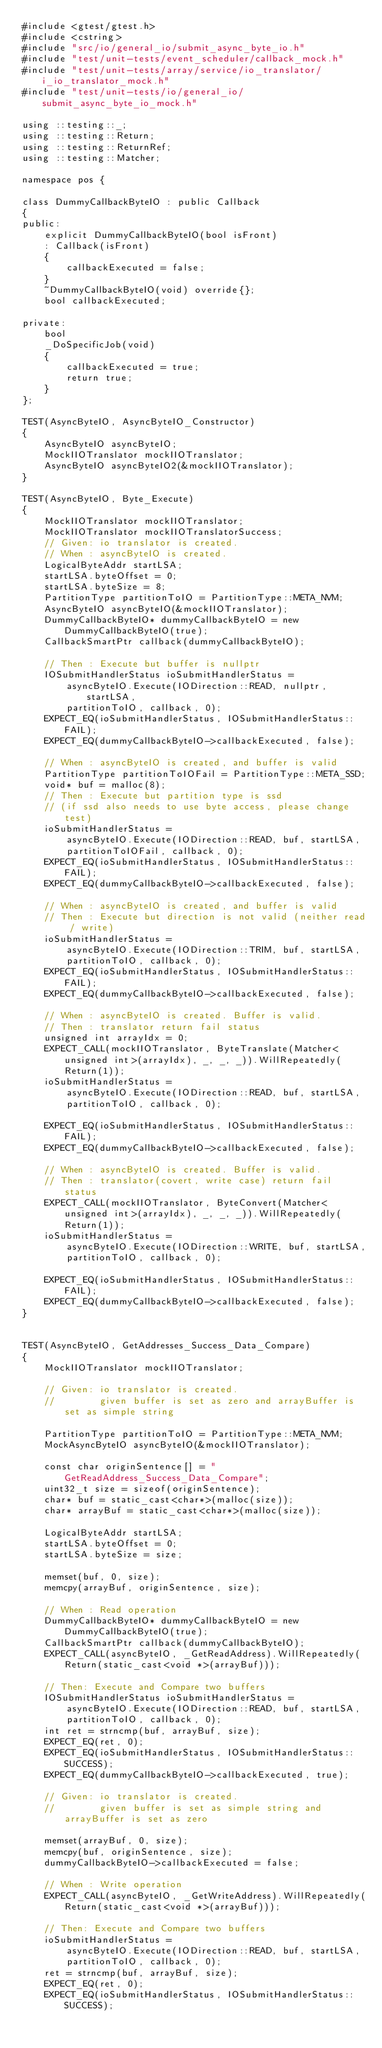<code> <loc_0><loc_0><loc_500><loc_500><_C++_>#include <gtest/gtest.h>
#include <cstring>
#include "src/io/general_io/submit_async_byte_io.h"
#include "test/unit-tests/event_scheduler/callback_mock.h"
#include "test/unit-tests/array/service/io_translator/i_io_translator_mock.h"
#include "test/unit-tests/io/general_io/submit_async_byte_io_mock.h"

using ::testing::_;
using ::testing::Return;
using ::testing::ReturnRef;
using ::testing::Matcher;

namespace pos {

class DummyCallbackByteIO : public Callback
{
public:
    explicit DummyCallbackByteIO(bool isFront)
    : Callback(isFront)
    {
        callbackExecuted = false;
    }
    ~DummyCallbackByteIO(void) override{};
    bool callbackExecuted;

private:
    bool
    _DoSpecificJob(void)
    {
        callbackExecuted = true;
        return true;
    }
};

TEST(AsyncByteIO, AsyncByteIO_Constructor)
{
    AsyncByteIO asyncByteIO;
    MockIIOTranslator mockIIOTranslator;
    AsyncByteIO asyncByteIO2(&mockIIOTranslator);
}

TEST(AsyncByteIO, Byte_Execute)
{
    MockIIOTranslator mockIIOTranslator;
    MockIIOTranslator mockIIOTranslatorSuccess;
    // Given: io translator is created.
    // When : asyncByteIO is created.
    LogicalByteAddr startLSA;
    startLSA.byteOffset = 0;
    startLSA.byteSize = 8;
    PartitionType partitionToIO = PartitionType::META_NVM;
    AsyncByteIO asyncByteIO(&mockIIOTranslator);
    DummyCallbackByteIO* dummyCallbackByteIO = new DummyCallbackByteIO(true);
    CallbackSmartPtr callback(dummyCallbackByteIO);

    // Then : Execute but buffer is nullptr
    IOSubmitHandlerStatus ioSubmitHandlerStatus =
        asyncByteIO.Execute(IODirection::READ, nullptr, startLSA,
        partitionToIO, callback, 0);
    EXPECT_EQ(ioSubmitHandlerStatus, IOSubmitHandlerStatus::FAIL);
    EXPECT_EQ(dummyCallbackByteIO->callbackExecuted, false);

    // When : asyncByteIO is created, and buffer is valid
    PartitionType partitionToIOFail = PartitionType::META_SSD;
    void* buf = malloc(8);
    // Then : Execute but partition type is ssd
    // (if ssd also needs to use byte access, please change test)
    ioSubmitHandlerStatus =
        asyncByteIO.Execute(IODirection::READ, buf, startLSA,
        partitionToIOFail, callback, 0);
    EXPECT_EQ(ioSubmitHandlerStatus, IOSubmitHandlerStatus::FAIL);
    EXPECT_EQ(dummyCallbackByteIO->callbackExecuted, false);

    // When : asyncByteIO is created, and buffer is valid
    // Then : Execute but direction is not valid (neither read / write)
    ioSubmitHandlerStatus =
        asyncByteIO.Execute(IODirection::TRIM, buf, startLSA,
        partitionToIO, callback, 0);
    EXPECT_EQ(ioSubmitHandlerStatus, IOSubmitHandlerStatus::FAIL);
    EXPECT_EQ(dummyCallbackByteIO->callbackExecuted, false);

    // When : asyncByteIO is created. Buffer is valid.
    // Then : translator return fail status
    unsigned int arrayIdx = 0;
    EXPECT_CALL(mockIIOTranslator, ByteTranslate(Matcher<unsigned int>(arrayIdx), _, _, _)).WillRepeatedly(Return(1));
    ioSubmitHandlerStatus =
        asyncByteIO.Execute(IODirection::READ, buf, startLSA,
        partitionToIO, callback, 0);

    EXPECT_EQ(ioSubmitHandlerStatus, IOSubmitHandlerStatus::FAIL);
    EXPECT_EQ(dummyCallbackByteIO->callbackExecuted, false);

    // When : asyncByteIO is created. Buffer is valid.
    // Then : translator(covert, write case) return fail status
    EXPECT_CALL(mockIIOTranslator, ByteConvert(Matcher<unsigned int>(arrayIdx), _, _, _)).WillRepeatedly(Return(1));
    ioSubmitHandlerStatus =
        asyncByteIO.Execute(IODirection::WRITE, buf, startLSA,
        partitionToIO, callback, 0);

    EXPECT_EQ(ioSubmitHandlerStatus, IOSubmitHandlerStatus::FAIL);
    EXPECT_EQ(dummyCallbackByteIO->callbackExecuted, false);
}


TEST(AsyncByteIO, GetAddresses_Success_Data_Compare)
{
    MockIIOTranslator mockIIOTranslator;

    // Given: io translator is created.
    //        given buffer is set as zero and arrayBuffer is set as simple string

    PartitionType partitionToIO = PartitionType::META_NVM;
    MockAsyncByteIO asyncByteIO(&mockIIOTranslator);

    const char originSentence[] = "GetReadAddress_Success_Data_Compare";
    uint32_t size = sizeof(originSentence);
    char* buf = static_cast<char*>(malloc(size));
    char* arrayBuf = static_cast<char*>(malloc(size));

    LogicalByteAddr startLSA;
    startLSA.byteOffset = 0;
    startLSA.byteSize = size;

    memset(buf, 0, size);
    memcpy(arrayBuf, originSentence, size);

    // When : Read operation
    DummyCallbackByteIO* dummyCallbackByteIO = new DummyCallbackByteIO(true);
    CallbackSmartPtr callback(dummyCallbackByteIO);
    EXPECT_CALL(asyncByteIO, _GetReadAddress).WillRepeatedly(Return(static_cast<void *>(arrayBuf)));

    // Then: Execute and Compare two buffers
    IOSubmitHandlerStatus ioSubmitHandlerStatus =
        asyncByteIO.Execute(IODirection::READ, buf, startLSA,
        partitionToIO, callback, 0);
    int ret = strncmp(buf, arrayBuf, size);
    EXPECT_EQ(ret, 0);
    EXPECT_EQ(ioSubmitHandlerStatus, IOSubmitHandlerStatus::SUCCESS);
    EXPECT_EQ(dummyCallbackByteIO->callbackExecuted, true);

    // Given: io translator is created.
    //        given buffer is set as simple string and arrayBuffer is set as zero

    memset(arrayBuf, 0, size);
    memcpy(buf, originSentence, size);
    dummyCallbackByteIO->callbackExecuted = false;

    // When : Write operation
    EXPECT_CALL(asyncByteIO, _GetWriteAddress).WillRepeatedly(Return(static_cast<void *>(arrayBuf)));

    // Then: Execute and Compare two buffers
    ioSubmitHandlerStatus =
        asyncByteIO.Execute(IODirection::READ, buf, startLSA,
        partitionToIO, callback, 0);
    ret = strncmp(buf, arrayBuf, size);
    EXPECT_EQ(ret, 0);
    EXPECT_EQ(ioSubmitHandlerStatus, IOSubmitHandlerStatus::SUCCESS);</code> 